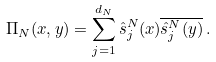Convert formula to latex. <formula><loc_0><loc_0><loc_500><loc_500>\Pi _ { N } ( x , y ) = \sum _ { j = 1 } ^ { d _ { N } } \hat { s } ^ { N } _ { j } ( x ) \overline { \hat { s } ^ { N } _ { j } ( y ) } \, .</formula> 